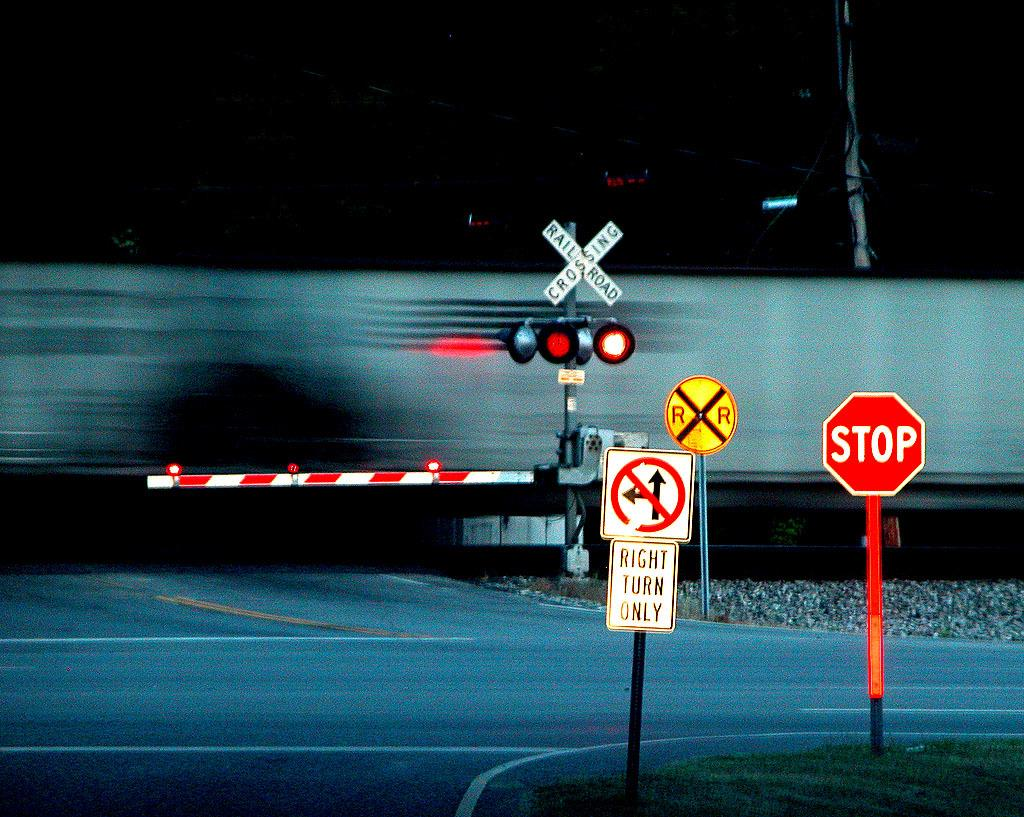<image>
Write a terse but informative summary of the picture. a stop sign that is in front of a large train 